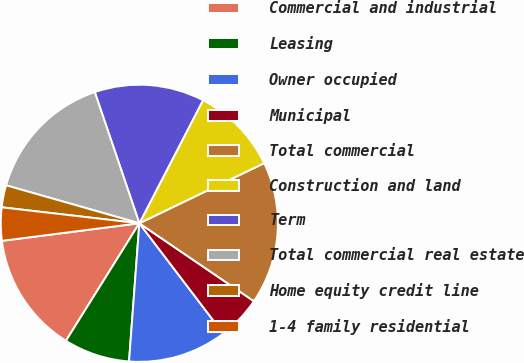<chart> <loc_0><loc_0><loc_500><loc_500><pie_chart><fcel>Commercial and industrial<fcel>Leasing<fcel>Owner occupied<fcel>Municipal<fcel>Total commercial<fcel>Construction and land<fcel>Term<fcel>Total commercial real estate<fcel>Home equity credit line<fcel>1-4 family residential<nl><fcel>14.09%<fcel>7.7%<fcel>11.54%<fcel>5.14%<fcel>16.65%<fcel>10.26%<fcel>12.81%<fcel>15.37%<fcel>2.58%<fcel>3.86%<nl></chart> 